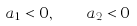<formula> <loc_0><loc_0><loc_500><loc_500>a _ { 1 } < 0 , \quad a _ { 2 } < 0</formula> 